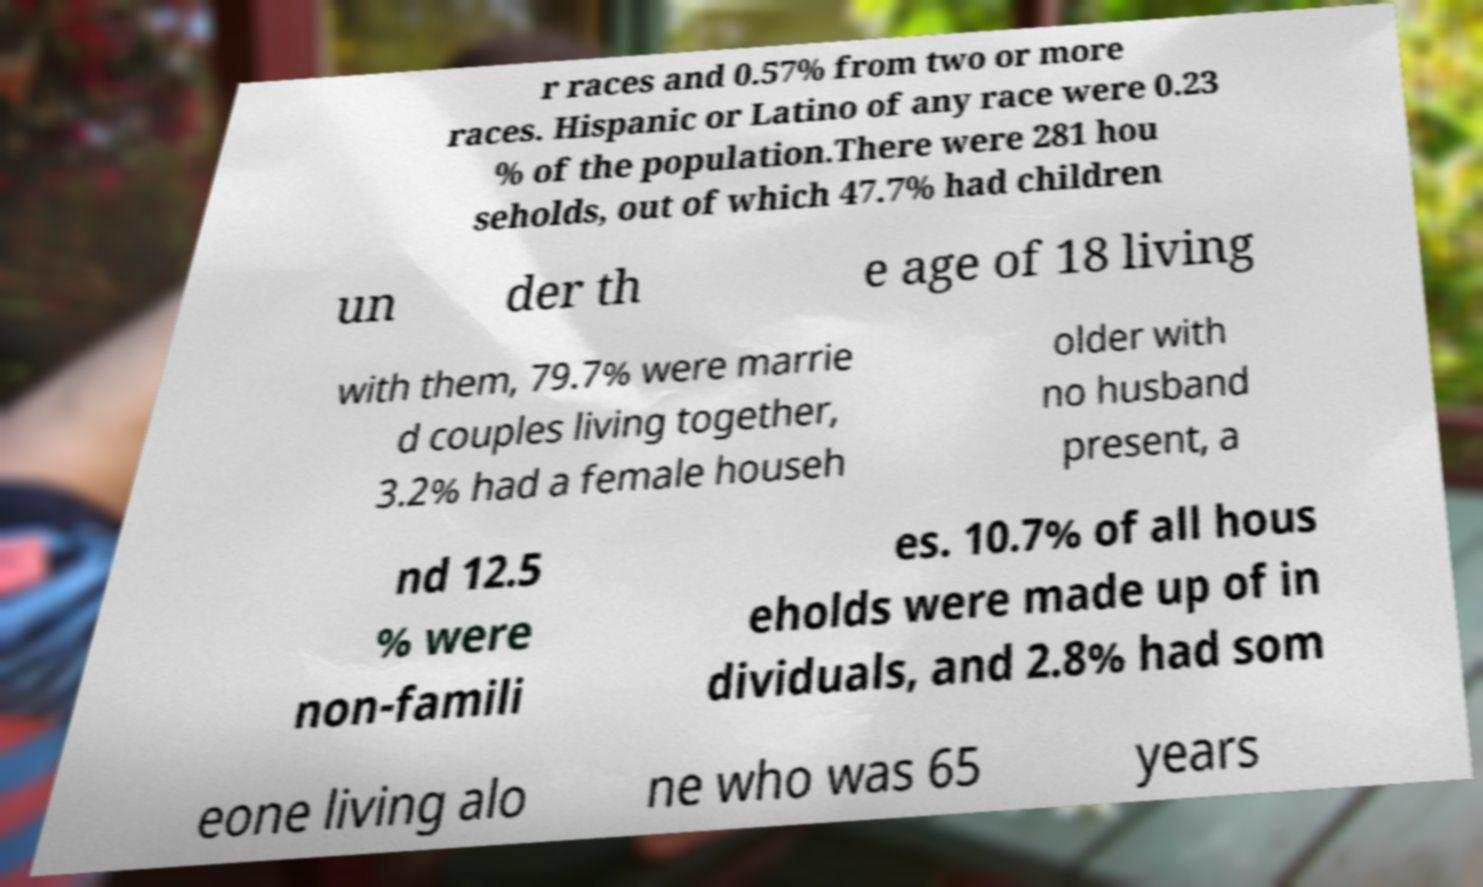Can you accurately transcribe the text from the provided image for me? r races and 0.57% from two or more races. Hispanic or Latino of any race were 0.23 % of the population.There were 281 hou seholds, out of which 47.7% had children un der th e age of 18 living with them, 79.7% were marrie d couples living together, 3.2% had a female househ older with no husband present, a nd 12.5 % were non-famili es. 10.7% of all hous eholds were made up of in dividuals, and 2.8% had som eone living alo ne who was 65 years 